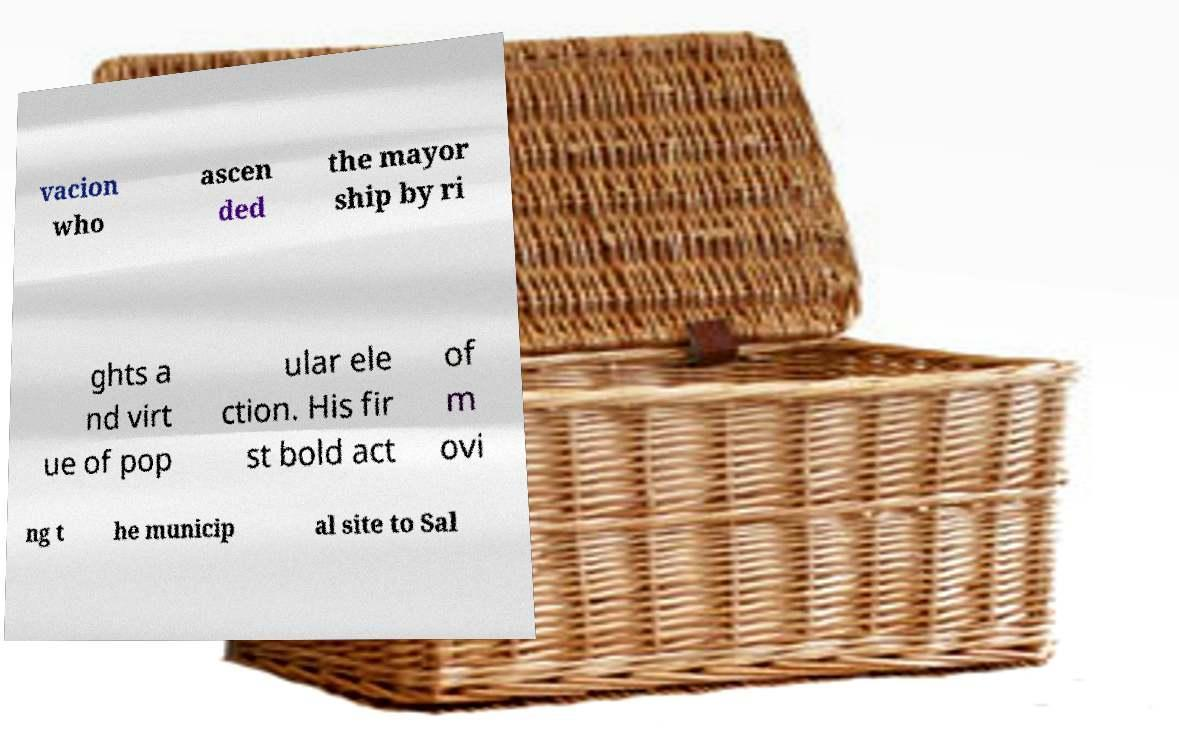There's text embedded in this image that I need extracted. Can you transcribe it verbatim? vacion who ascen ded the mayor ship by ri ghts a nd virt ue of pop ular ele ction. His fir st bold act of m ovi ng t he municip al site to Sal 